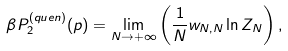<formula> <loc_0><loc_0><loc_500><loc_500>\beta P ^ { ( q u e n ) } _ { 2 } ( p ) = \lim _ { N \to + \infty } \left ( \frac { 1 } { N } w _ { N , N } \ln { Z _ { N } } \right ) ,</formula> 